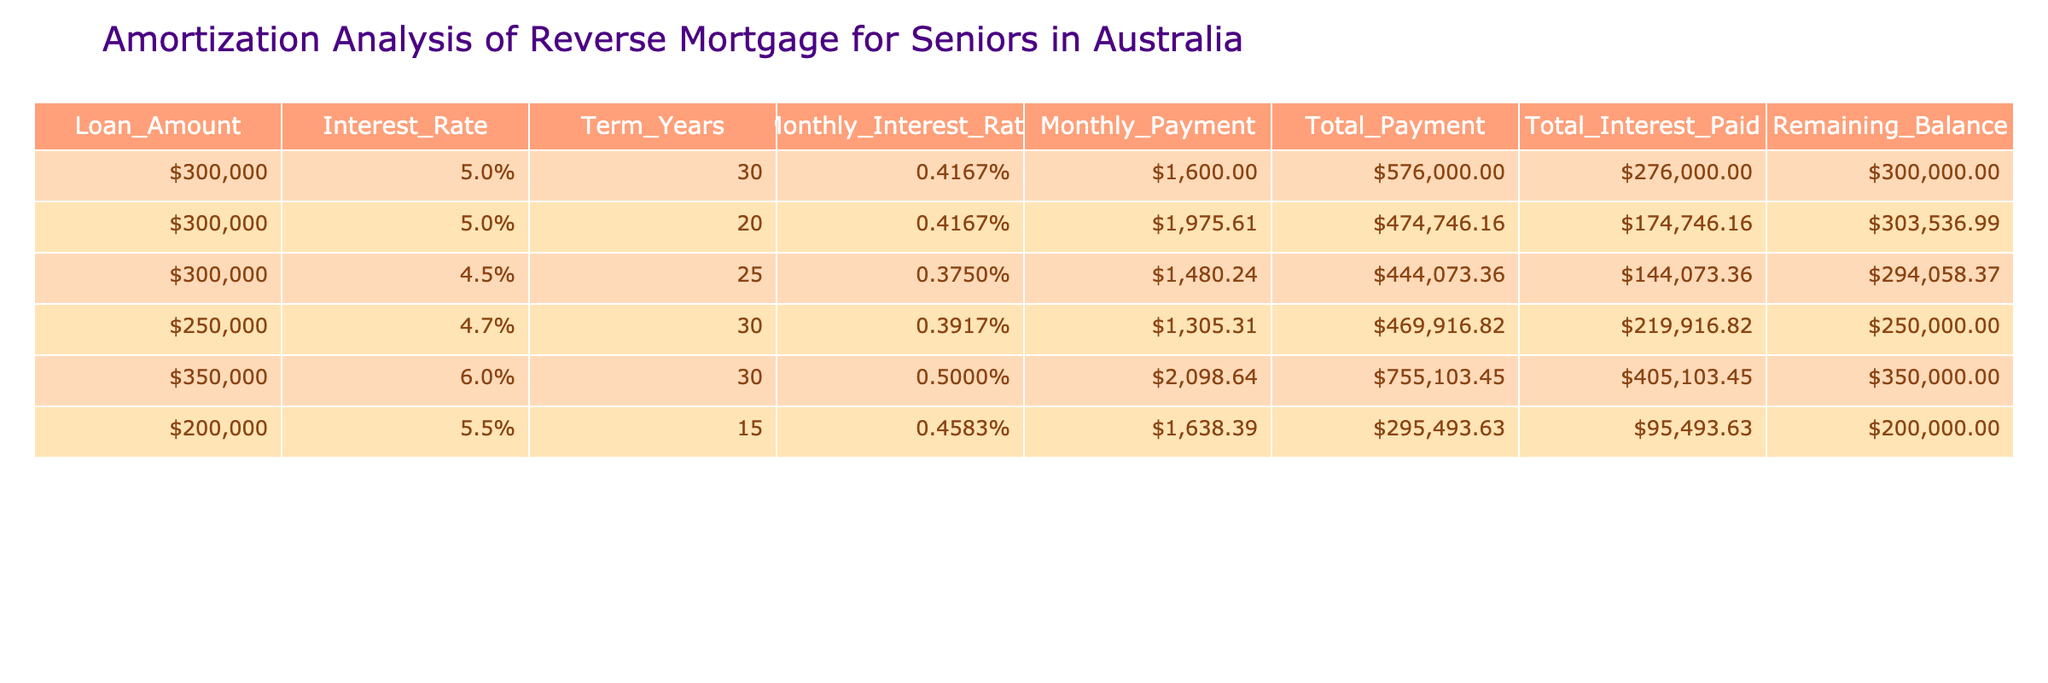What is the highest total payment among the loans? By looking at the Total Payment column, the highest total payment is for the loan with an amount of $350,000, which totals $755,103.45.
Answer: $755,103.45 Which loan has the lowest interest rate? The interest rates for each loan can be found in the Interest Rate column. The loan with an amount of $250,000 has the lowest interest rate at 4.7%.
Answer: 4.7% How much total interest would a $300,000 loan at 4.5% for 25 years incur? The Total Interest Paid for the $300,000 loan at 4.5% for 25 years is listed in the table as $144,073.36.
Answer: $144,073.36 Is the monthly payment for a $200,000 reverse mortgage greater than $1,600? The Monthly Payment for the $200,000 reverse mortgage is $1,638.39, which is greater than $1,600.
Answer: Yes What is the remaining balance of the loan with the shortest term? The shortest term in the table is for the $200,000 loan at 15 years. The Remaining Balance for this loan is shown as $200,000.
Answer: $200,000 What is the average monthly payment across all loans listed? To find the average, add the Monthly Payments: $1600 + $1975.61 + $1480.24 + $1305.31 + $2098.64 + $1638.39 = $10998.19. There are 6 loans, so the average is $10998.19 / 6 = $1833.03.
Answer: $1,833.03 Does any loan result in total payments exceeding $500,000? By looking at the Total Payment column, the loans for $300,000 (30 years), $350,000 (30 years), and the $250,000 loan all exceed $500,000.
Answer: Yes What is the difference in total payments between the loan at 5% for 30 years and the loan at 5.5% for 15 years? The Total Payment for the $300,000 loan at 5% for 30 years is $576,000, and for the $200,000 loan at 5.5% for 15 years, it is $295,493.63. The difference is $576,000 - $295,493.63 = $280,506.37.
Answer: $280,506.37 